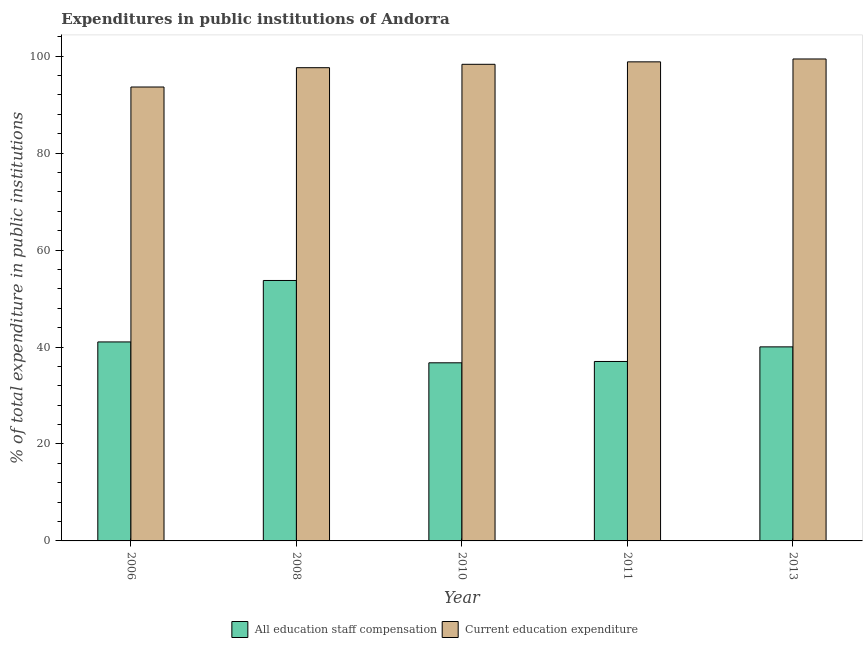Are the number of bars on each tick of the X-axis equal?
Keep it short and to the point. Yes. What is the expenditure in education in 2006?
Provide a short and direct response. 93.63. Across all years, what is the maximum expenditure in staff compensation?
Keep it short and to the point. 53.72. Across all years, what is the minimum expenditure in education?
Offer a very short reply. 93.63. What is the total expenditure in education in the graph?
Provide a succinct answer. 487.81. What is the difference between the expenditure in staff compensation in 2010 and that in 2013?
Your response must be concise. -3.28. What is the difference between the expenditure in education in 2013 and the expenditure in staff compensation in 2006?
Keep it short and to the point. 5.78. What is the average expenditure in staff compensation per year?
Your answer should be very brief. 41.71. In the year 2011, what is the difference between the expenditure in staff compensation and expenditure in education?
Provide a succinct answer. 0. In how many years, is the expenditure in education greater than 64 %?
Your answer should be very brief. 5. What is the ratio of the expenditure in education in 2010 to that in 2011?
Make the answer very short. 0.99. Is the difference between the expenditure in staff compensation in 2008 and 2013 greater than the difference between the expenditure in education in 2008 and 2013?
Your answer should be compact. No. What is the difference between the highest and the second highest expenditure in staff compensation?
Offer a terse response. 12.68. What is the difference between the highest and the lowest expenditure in education?
Make the answer very short. 5.78. In how many years, is the expenditure in education greater than the average expenditure in education taken over all years?
Your answer should be very brief. 4. Is the sum of the expenditure in staff compensation in 2010 and 2011 greater than the maximum expenditure in education across all years?
Ensure brevity in your answer.  Yes. What does the 1st bar from the left in 2006 represents?
Make the answer very short. All education staff compensation. What does the 1st bar from the right in 2008 represents?
Your answer should be very brief. Current education expenditure. Are all the bars in the graph horizontal?
Your response must be concise. No. What is the difference between two consecutive major ticks on the Y-axis?
Provide a short and direct response. 20. Does the graph contain any zero values?
Your answer should be compact. No. How many legend labels are there?
Provide a succinct answer. 2. How are the legend labels stacked?
Your answer should be compact. Horizontal. What is the title of the graph?
Ensure brevity in your answer.  Expenditures in public institutions of Andorra. What is the label or title of the Y-axis?
Ensure brevity in your answer.  % of total expenditure in public institutions. What is the % of total expenditure in public institutions in All education staff compensation in 2006?
Your response must be concise. 41.05. What is the % of total expenditure in public institutions in Current education expenditure in 2006?
Keep it short and to the point. 93.63. What is the % of total expenditure in public institutions in All education staff compensation in 2008?
Keep it short and to the point. 53.72. What is the % of total expenditure in public institutions in Current education expenditure in 2008?
Offer a terse response. 97.62. What is the % of total expenditure in public institutions in All education staff compensation in 2010?
Your answer should be very brief. 36.74. What is the % of total expenditure in public institutions of Current education expenditure in 2010?
Your response must be concise. 98.32. What is the % of total expenditure in public institutions in All education staff compensation in 2011?
Make the answer very short. 37.02. What is the % of total expenditure in public institutions in Current education expenditure in 2011?
Your response must be concise. 98.82. What is the % of total expenditure in public institutions in All education staff compensation in 2013?
Your answer should be compact. 40.03. What is the % of total expenditure in public institutions in Current education expenditure in 2013?
Provide a succinct answer. 99.42. Across all years, what is the maximum % of total expenditure in public institutions of All education staff compensation?
Ensure brevity in your answer.  53.72. Across all years, what is the maximum % of total expenditure in public institutions in Current education expenditure?
Give a very brief answer. 99.42. Across all years, what is the minimum % of total expenditure in public institutions of All education staff compensation?
Your answer should be very brief. 36.74. Across all years, what is the minimum % of total expenditure in public institutions in Current education expenditure?
Ensure brevity in your answer.  93.63. What is the total % of total expenditure in public institutions in All education staff compensation in the graph?
Provide a succinct answer. 208.56. What is the total % of total expenditure in public institutions in Current education expenditure in the graph?
Your answer should be very brief. 487.81. What is the difference between the % of total expenditure in public institutions of All education staff compensation in 2006 and that in 2008?
Your answer should be very brief. -12.68. What is the difference between the % of total expenditure in public institutions of Current education expenditure in 2006 and that in 2008?
Give a very brief answer. -3.98. What is the difference between the % of total expenditure in public institutions of All education staff compensation in 2006 and that in 2010?
Provide a succinct answer. 4.3. What is the difference between the % of total expenditure in public institutions of Current education expenditure in 2006 and that in 2010?
Offer a very short reply. -4.68. What is the difference between the % of total expenditure in public institutions in All education staff compensation in 2006 and that in 2011?
Make the answer very short. 4.03. What is the difference between the % of total expenditure in public institutions in Current education expenditure in 2006 and that in 2011?
Make the answer very short. -5.19. What is the difference between the % of total expenditure in public institutions of All education staff compensation in 2006 and that in 2013?
Offer a very short reply. 1.02. What is the difference between the % of total expenditure in public institutions of Current education expenditure in 2006 and that in 2013?
Offer a very short reply. -5.78. What is the difference between the % of total expenditure in public institutions of All education staff compensation in 2008 and that in 2010?
Your response must be concise. 16.98. What is the difference between the % of total expenditure in public institutions in Current education expenditure in 2008 and that in 2010?
Your answer should be compact. -0.7. What is the difference between the % of total expenditure in public institutions in All education staff compensation in 2008 and that in 2011?
Offer a very short reply. 16.71. What is the difference between the % of total expenditure in public institutions of Current education expenditure in 2008 and that in 2011?
Give a very brief answer. -1.21. What is the difference between the % of total expenditure in public institutions of All education staff compensation in 2008 and that in 2013?
Provide a succinct answer. 13.7. What is the difference between the % of total expenditure in public institutions in Current education expenditure in 2008 and that in 2013?
Provide a succinct answer. -1.8. What is the difference between the % of total expenditure in public institutions in All education staff compensation in 2010 and that in 2011?
Give a very brief answer. -0.27. What is the difference between the % of total expenditure in public institutions in Current education expenditure in 2010 and that in 2011?
Ensure brevity in your answer.  -0.51. What is the difference between the % of total expenditure in public institutions of All education staff compensation in 2010 and that in 2013?
Your answer should be very brief. -3.28. What is the difference between the % of total expenditure in public institutions in Current education expenditure in 2010 and that in 2013?
Keep it short and to the point. -1.1. What is the difference between the % of total expenditure in public institutions in All education staff compensation in 2011 and that in 2013?
Provide a short and direct response. -3.01. What is the difference between the % of total expenditure in public institutions in Current education expenditure in 2011 and that in 2013?
Your answer should be very brief. -0.59. What is the difference between the % of total expenditure in public institutions in All education staff compensation in 2006 and the % of total expenditure in public institutions in Current education expenditure in 2008?
Your answer should be compact. -56.57. What is the difference between the % of total expenditure in public institutions of All education staff compensation in 2006 and the % of total expenditure in public institutions of Current education expenditure in 2010?
Offer a terse response. -57.27. What is the difference between the % of total expenditure in public institutions of All education staff compensation in 2006 and the % of total expenditure in public institutions of Current education expenditure in 2011?
Your response must be concise. -57.78. What is the difference between the % of total expenditure in public institutions of All education staff compensation in 2006 and the % of total expenditure in public institutions of Current education expenditure in 2013?
Give a very brief answer. -58.37. What is the difference between the % of total expenditure in public institutions of All education staff compensation in 2008 and the % of total expenditure in public institutions of Current education expenditure in 2010?
Ensure brevity in your answer.  -44.59. What is the difference between the % of total expenditure in public institutions of All education staff compensation in 2008 and the % of total expenditure in public institutions of Current education expenditure in 2011?
Offer a terse response. -45.1. What is the difference between the % of total expenditure in public institutions in All education staff compensation in 2008 and the % of total expenditure in public institutions in Current education expenditure in 2013?
Offer a very short reply. -45.69. What is the difference between the % of total expenditure in public institutions of All education staff compensation in 2010 and the % of total expenditure in public institutions of Current education expenditure in 2011?
Offer a terse response. -62.08. What is the difference between the % of total expenditure in public institutions of All education staff compensation in 2010 and the % of total expenditure in public institutions of Current education expenditure in 2013?
Ensure brevity in your answer.  -62.67. What is the difference between the % of total expenditure in public institutions of All education staff compensation in 2011 and the % of total expenditure in public institutions of Current education expenditure in 2013?
Make the answer very short. -62.4. What is the average % of total expenditure in public institutions in All education staff compensation per year?
Make the answer very short. 41.71. What is the average % of total expenditure in public institutions in Current education expenditure per year?
Keep it short and to the point. 97.56. In the year 2006, what is the difference between the % of total expenditure in public institutions of All education staff compensation and % of total expenditure in public institutions of Current education expenditure?
Offer a terse response. -52.59. In the year 2008, what is the difference between the % of total expenditure in public institutions of All education staff compensation and % of total expenditure in public institutions of Current education expenditure?
Give a very brief answer. -43.89. In the year 2010, what is the difference between the % of total expenditure in public institutions of All education staff compensation and % of total expenditure in public institutions of Current education expenditure?
Offer a terse response. -61.57. In the year 2011, what is the difference between the % of total expenditure in public institutions in All education staff compensation and % of total expenditure in public institutions in Current education expenditure?
Your answer should be compact. -61.81. In the year 2013, what is the difference between the % of total expenditure in public institutions in All education staff compensation and % of total expenditure in public institutions in Current education expenditure?
Your response must be concise. -59.39. What is the ratio of the % of total expenditure in public institutions of All education staff compensation in 2006 to that in 2008?
Your response must be concise. 0.76. What is the ratio of the % of total expenditure in public institutions of Current education expenditure in 2006 to that in 2008?
Offer a very short reply. 0.96. What is the ratio of the % of total expenditure in public institutions in All education staff compensation in 2006 to that in 2010?
Give a very brief answer. 1.12. What is the ratio of the % of total expenditure in public institutions of Current education expenditure in 2006 to that in 2010?
Provide a succinct answer. 0.95. What is the ratio of the % of total expenditure in public institutions of All education staff compensation in 2006 to that in 2011?
Make the answer very short. 1.11. What is the ratio of the % of total expenditure in public institutions in Current education expenditure in 2006 to that in 2011?
Ensure brevity in your answer.  0.95. What is the ratio of the % of total expenditure in public institutions of All education staff compensation in 2006 to that in 2013?
Provide a short and direct response. 1.03. What is the ratio of the % of total expenditure in public institutions of Current education expenditure in 2006 to that in 2013?
Your response must be concise. 0.94. What is the ratio of the % of total expenditure in public institutions of All education staff compensation in 2008 to that in 2010?
Give a very brief answer. 1.46. What is the ratio of the % of total expenditure in public institutions of All education staff compensation in 2008 to that in 2011?
Offer a terse response. 1.45. What is the ratio of the % of total expenditure in public institutions of All education staff compensation in 2008 to that in 2013?
Offer a very short reply. 1.34. What is the ratio of the % of total expenditure in public institutions of Current education expenditure in 2008 to that in 2013?
Ensure brevity in your answer.  0.98. What is the ratio of the % of total expenditure in public institutions in All education staff compensation in 2010 to that in 2013?
Give a very brief answer. 0.92. What is the ratio of the % of total expenditure in public institutions in Current education expenditure in 2010 to that in 2013?
Provide a succinct answer. 0.99. What is the ratio of the % of total expenditure in public institutions of All education staff compensation in 2011 to that in 2013?
Offer a very short reply. 0.92. What is the difference between the highest and the second highest % of total expenditure in public institutions of All education staff compensation?
Make the answer very short. 12.68. What is the difference between the highest and the second highest % of total expenditure in public institutions of Current education expenditure?
Provide a short and direct response. 0.59. What is the difference between the highest and the lowest % of total expenditure in public institutions in All education staff compensation?
Your answer should be compact. 16.98. What is the difference between the highest and the lowest % of total expenditure in public institutions in Current education expenditure?
Your response must be concise. 5.78. 